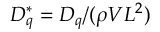Convert formula to latex. <formula><loc_0><loc_0><loc_500><loc_500>D _ { q } ^ { * } = D _ { q } / ( \rho V L ^ { 2 } )</formula> 